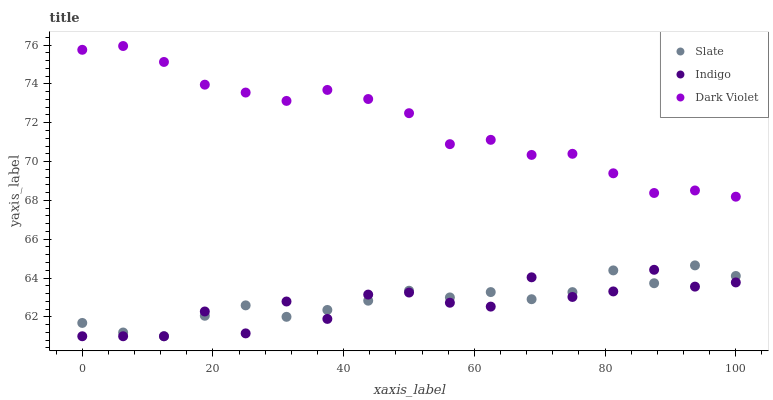Does Indigo have the minimum area under the curve?
Answer yes or no. Yes. Does Dark Violet have the maximum area under the curve?
Answer yes or no. Yes. Does Dark Violet have the minimum area under the curve?
Answer yes or no. No. Does Indigo have the maximum area under the curve?
Answer yes or no. No. Is Dark Violet the smoothest?
Answer yes or no. Yes. Is Indigo the roughest?
Answer yes or no. Yes. Is Indigo the smoothest?
Answer yes or no. No. Is Dark Violet the roughest?
Answer yes or no. No. Does Slate have the lowest value?
Answer yes or no. Yes. Does Dark Violet have the lowest value?
Answer yes or no. No. Does Dark Violet have the highest value?
Answer yes or no. Yes. Does Indigo have the highest value?
Answer yes or no. No. Is Indigo less than Dark Violet?
Answer yes or no. Yes. Is Dark Violet greater than Slate?
Answer yes or no. Yes. Does Indigo intersect Slate?
Answer yes or no. Yes. Is Indigo less than Slate?
Answer yes or no. No. Is Indigo greater than Slate?
Answer yes or no. No. Does Indigo intersect Dark Violet?
Answer yes or no. No. 